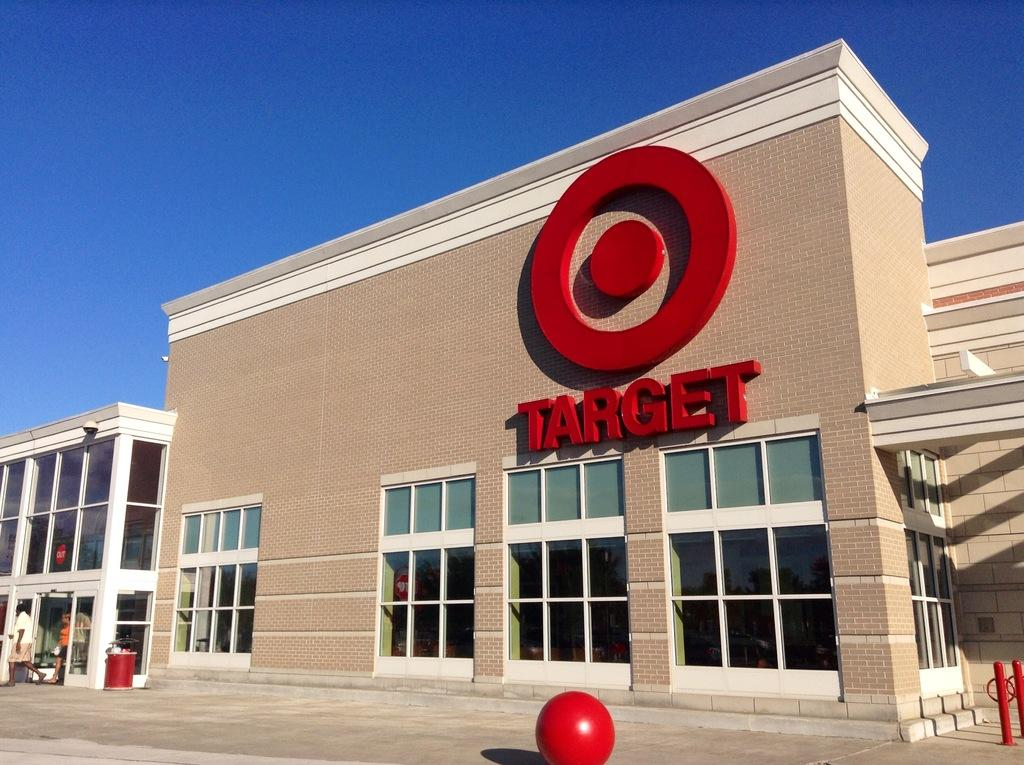What is the name of the building in the image? The building has "target" written on it in the image. What is located in front of the building? There is a red color ball in front of the building. How many people are in the image? There are two persons in the image. What can be seen in the left corner of the image? There is a building in the left corner of the image. What type of calculator is being used during the meeting in the image? There is no calculator or meeting present in the image. What sound can be heard coming from the building in the image? The image does not provide any information about sounds or meetings, so it cannot be determined from the image. 